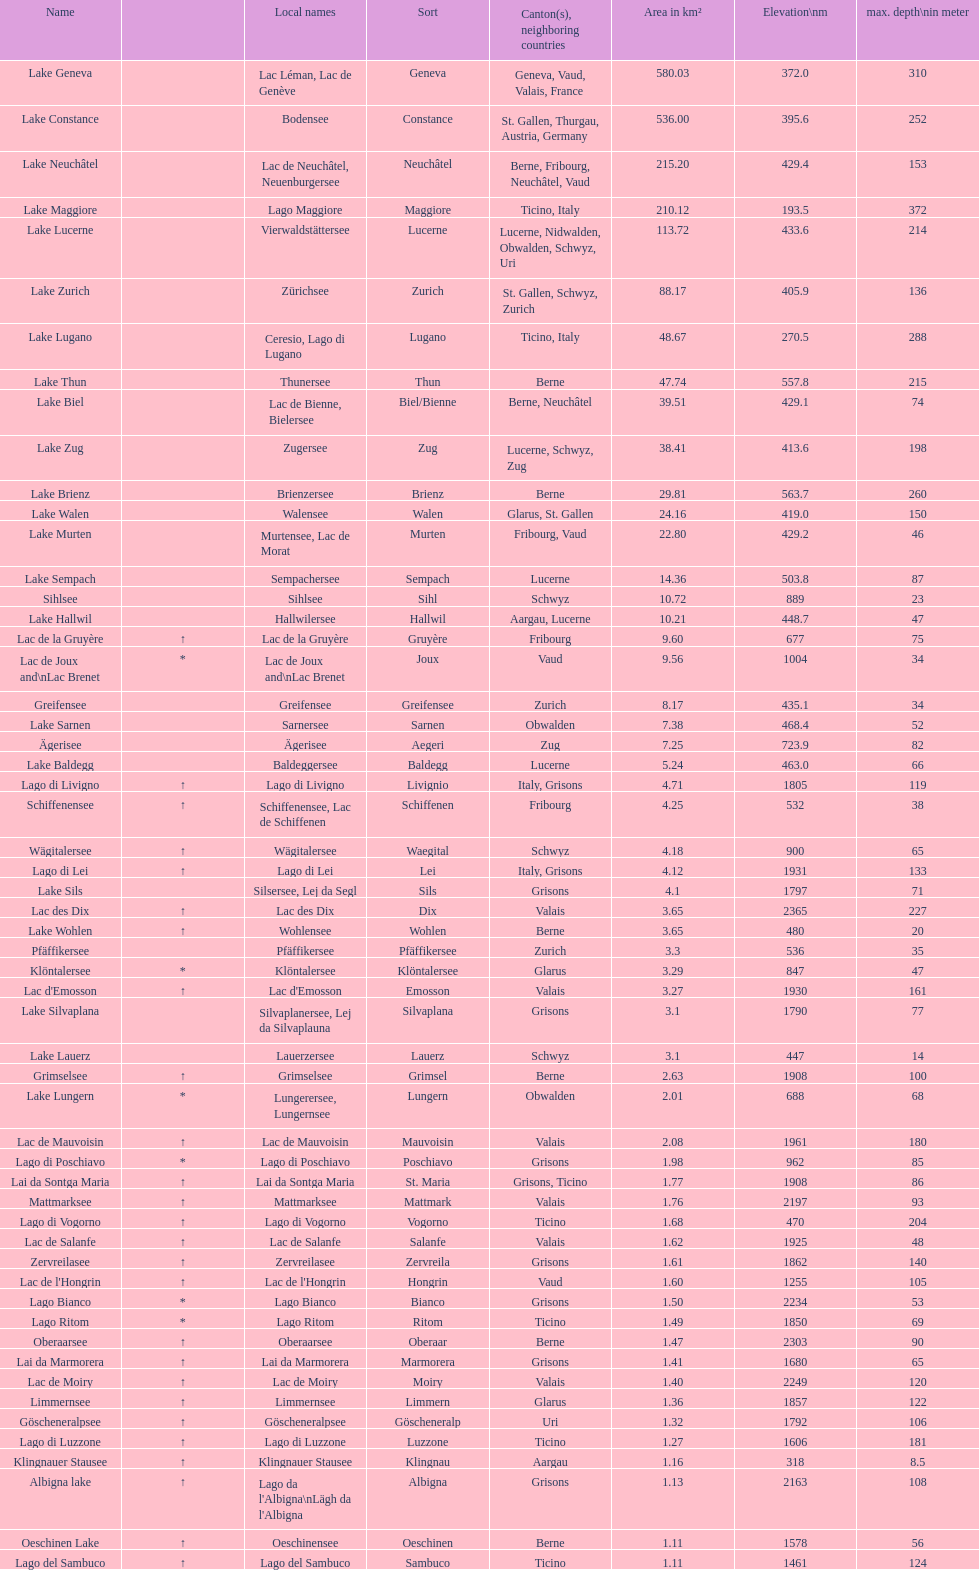At the highest elevation, which lake can be found? Lac des Dix. 